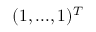<formula> <loc_0><loc_0><loc_500><loc_500>( 1 , \dots , 1 ) ^ { T }</formula> 